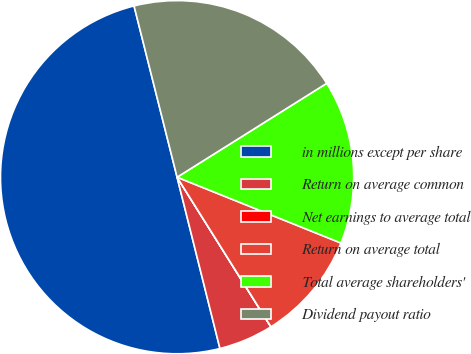Convert chart. <chart><loc_0><loc_0><loc_500><loc_500><pie_chart><fcel>in millions except per share<fcel>Return on average common<fcel>Net earnings to average total<fcel>Return on average total<fcel>Total average shareholders'<fcel>Dividend payout ratio<nl><fcel>49.98%<fcel>5.01%<fcel>0.01%<fcel>10.0%<fcel>15.0%<fcel>20.0%<nl></chart> 